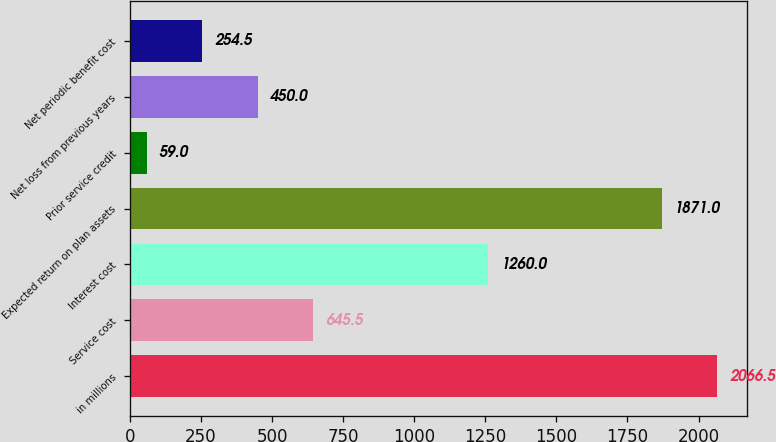<chart> <loc_0><loc_0><loc_500><loc_500><bar_chart><fcel>in millions<fcel>Service cost<fcel>Interest cost<fcel>Expected return on plan assets<fcel>Prior service credit<fcel>Net loss from previous years<fcel>Net periodic benefit cost<nl><fcel>2066.5<fcel>645.5<fcel>1260<fcel>1871<fcel>59<fcel>450<fcel>254.5<nl></chart> 